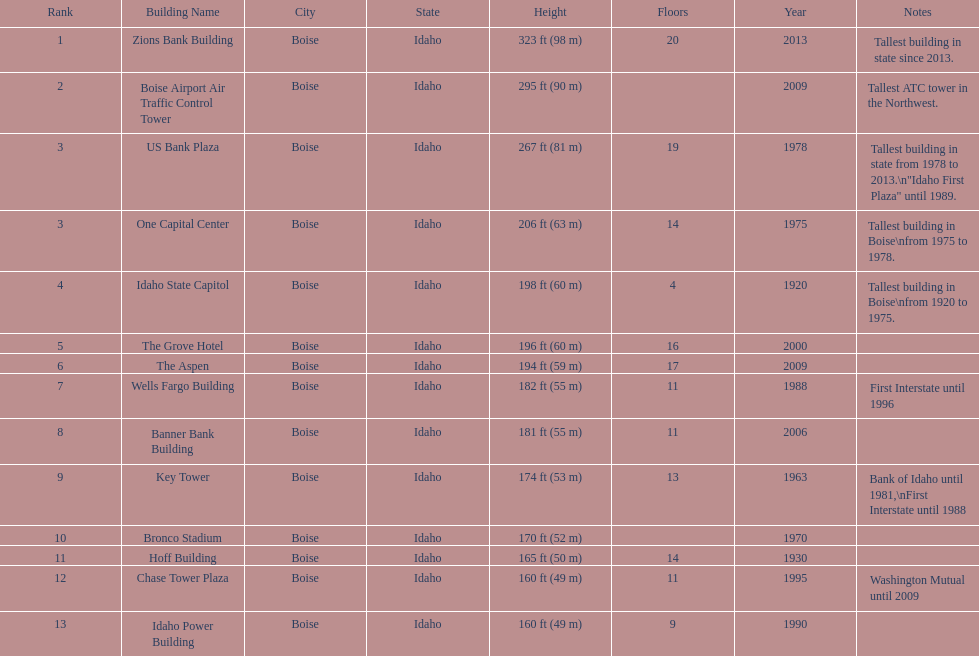What is the tallest building in bosie, idaho? Zions Bank Building Zions Bank Building in Downtown Boise, Idaho. Can you give me this table as a dict? {'header': ['Rank', 'Building Name', 'City', 'State', 'Height', 'Floors', 'Year', 'Notes'], 'rows': [['1', 'Zions Bank Building', 'Boise', 'Idaho', '323\xa0ft (98\xa0m)', '20', '2013', 'Tallest building in state since 2013.'], ['2', 'Boise Airport Air Traffic Control Tower', 'Boise', 'Idaho', '295\xa0ft (90\xa0m)', '', '2009', 'Tallest ATC tower in the Northwest.'], ['3', 'US Bank Plaza', 'Boise', 'Idaho', '267\xa0ft (81\xa0m)', '19', '1978', 'Tallest building in state from 1978 to 2013.\\n"Idaho First Plaza" until 1989.'], ['3', 'One Capital Center', 'Boise', 'Idaho', '206\xa0ft (63\xa0m)', '14', '1975', 'Tallest building in Boise\\nfrom 1975 to 1978.'], ['4', 'Idaho State Capitol', 'Boise', 'Idaho', '198\xa0ft (60\xa0m)', '4', '1920', 'Tallest building in Boise\\nfrom 1920 to 1975.'], ['5', 'The Grove Hotel', 'Boise', 'Idaho', '196\xa0ft (60\xa0m)', '16', '2000', ''], ['6', 'The Aspen', 'Boise', 'Idaho', '194\xa0ft (59\xa0m)', '17', '2009', ''], ['7', 'Wells Fargo Building', 'Boise', 'Idaho', '182\xa0ft (55\xa0m)', '11', '1988', 'First Interstate until 1996'], ['8', 'Banner Bank Building', 'Boise', 'Idaho', '181\xa0ft (55\xa0m)', '11', '2006', ''], ['9', 'Key Tower', 'Boise', 'Idaho', '174\xa0ft (53\xa0m)', '13', '1963', 'Bank of Idaho until 1981,\\nFirst Interstate until 1988'], ['10', 'Bronco Stadium', 'Boise', 'Idaho', '170\xa0ft (52\xa0m)', '', '1970', ''], ['11', 'Hoff Building', 'Boise', 'Idaho', '165\xa0ft (50\xa0m)', '14', '1930', ''], ['12', 'Chase Tower Plaza', 'Boise', 'Idaho', '160\xa0ft (49\xa0m)', '11', '1995', 'Washington Mutual until 2009'], ['13', 'Idaho Power Building', 'Boise', 'Idaho', '160\xa0ft (49\xa0m)', '9', '1990', '']]} 